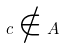Convert formula to latex. <formula><loc_0><loc_0><loc_500><loc_500>c \notin A</formula> 